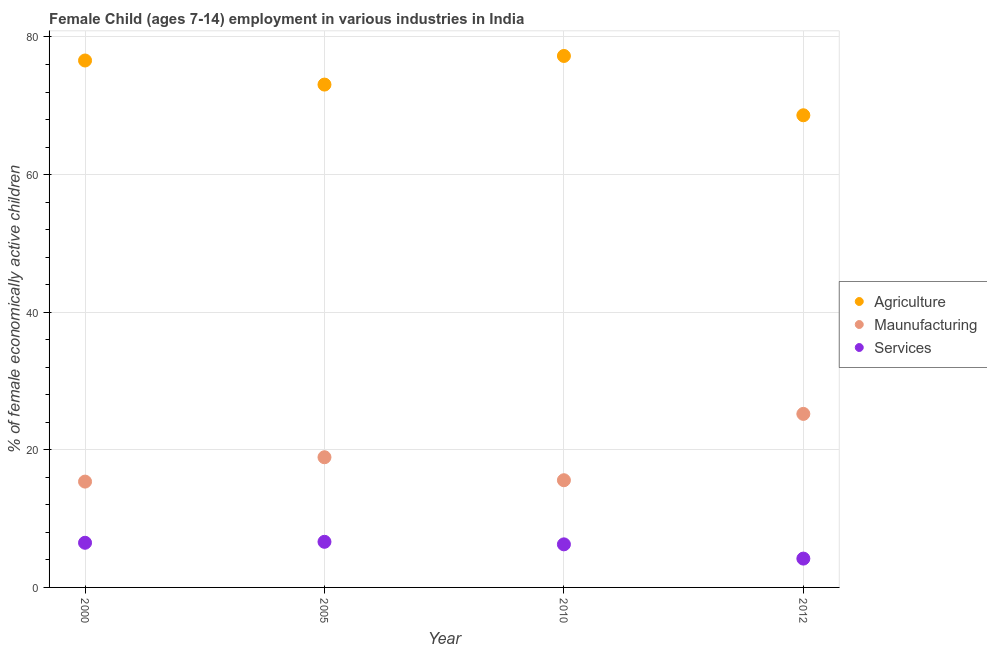What is the percentage of economically active children in services in 2005?
Keep it short and to the point. 6.63. Across all years, what is the maximum percentage of economically active children in agriculture?
Keep it short and to the point. 77.24. Across all years, what is the minimum percentage of economically active children in agriculture?
Offer a terse response. 68.62. In which year was the percentage of economically active children in manufacturing minimum?
Offer a very short reply. 2000. What is the total percentage of economically active children in services in the graph?
Your answer should be compact. 23.57. What is the difference between the percentage of economically active children in manufacturing in 2000 and that in 2010?
Make the answer very short. -0.2. What is the difference between the percentage of economically active children in services in 2012 and the percentage of economically active children in agriculture in 2000?
Your response must be concise. -72.39. What is the average percentage of economically active children in manufacturing per year?
Offer a very short reply. 18.77. In the year 2010, what is the difference between the percentage of economically active children in services and percentage of economically active children in manufacturing?
Provide a succinct answer. -9.32. What is the ratio of the percentage of economically active children in agriculture in 2000 to that in 2005?
Provide a short and direct response. 1.05. Is the difference between the percentage of economically active children in services in 2005 and 2010 greater than the difference between the percentage of economically active children in manufacturing in 2005 and 2010?
Offer a terse response. No. What is the difference between the highest and the second highest percentage of economically active children in services?
Provide a succinct answer. 0.14. What is the difference between the highest and the lowest percentage of economically active children in agriculture?
Your response must be concise. 8.62. In how many years, is the percentage of economically active children in services greater than the average percentage of economically active children in services taken over all years?
Your answer should be compact. 3. Does the percentage of economically active children in manufacturing monotonically increase over the years?
Provide a short and direct response. No. How many years are there in the graph?
Your answer should be very brief. 4. What is the difference between two consecutive major ticks on the Y-axis?
Your answer should be very brief. 20. Does the graph contain grids?
Your answer should be very brief. Yes. How many legend labels are there?
Provide a short and direct response. 3. What is the title of the graph?
Offer a terse response. Female Child (ages 7-14) employment in various industries in India. What is the label or title of the X-axis?
Your response must be concise. Year. What is the label or title of the Y-axis?
Offer a very short reply. % of female economically active children. What is the % of female economically active children in Agriculture in 2000?
Provide a short and direct response. 76.58. What is the % of female economically active children in Maunufacturing in 2000?
Give a very brief answer. 15.38. What is the % of female economically active children of Services in 2000?
Ensure brevity in your answer.  6.49. What is the % of female economically active children of Agriculture in 2005?
Provide a short and direct response. 73.08. What is the % of female economically active children of Maunufacturing in 2005?
Offer a terse response. 18.92. What is the % of female economically active children of Services in 2005?
Offer a very short reply. 6.63. What is the % of female economically active children in Agriculture in 2010?
Keep it short and to the point. 77.24. What is the % of female economically active children in Maunufacturing in 2010?
Your answer should be very brief. 15.58. What is the % of female economically active children of Services in 2010?
Your answer should be compact. 6.26. What is the % of female economically active children in Agriculture in 2012?
Give a very brief answer. 68.62. What is the % of female economically active children in Maunufacturing in 2012?
Offer a very short reply. 25.22. What is the % of female economically active children in Services in 2012?
Offer a terse response. 4.19. Across all years, what is the maximum % of female economically active children of Agriculture?
Give a very brief answer. 77.24. Across all years, what is the maximum % of female economically active children in Maunufacturing?
Ensure brevity in your answer.  25.22. Across all years, what is the maximum % of female economically active children of Services?
Your answer should be compact. 6.63. Across all years, what is the minimum % of female economically active children of Agriculture?
Make the answer very short. 68.62. Across all years, what is the minimum % of female economically active children in Maunufacturing?
Provide a succinct answer. 15.38. Across all years, what is the minimum % of female economically active children of Services?
Your answer should be compact. 4.19. What is the total % of female economically active children in Agriculture in the graph?
Provide a succinct answer. 295.52. What is the total % of female economically active children of Maunufacturing in the graph?
Your answer should be compact. 75.1. What is the total % of female economically active children in Services in the graph?
Offer a terse response. 23.57. What is the difference between the % of female economically active children in Agriculture in 2000 and that in 2005?
Offer a terse response. 3.5. What is the difference between the % of female economically active children in Maunufacturing in 2000 and that in 2005?
Ensure brevity in your answer.  -3.54. What is the difference between the % of female economically active children of Services in 2000 and that in 2005?
Provide a short and direct response. -0.14. What is the difference between the % of female economically active children of Agriculture in 2000 and that in 2010?
Provide a short and direct response. -0.66. What is the difference between the % of female economically active children of Services in 2000 and that in 2010?
Keep it short and to the point. 0.23. What is the difference between the % of female economically active children of Agriculture in 2000 and that in 2012?
Your answer should be very brief. 7.96. What is the difference between the % of female economically active children of Maunufacturing in 2000 and that in 2012?
Offer a very short reply. -9.84. What is the difference between the % of female economically active children of Agriculture in 2005 and that in 2010?
Offer a terse response. -4.16. What is the difference between the % of female economically active children in Maunufacturing in 2005 and that in 2010?
Keep it short and to the point. 3.34. What is the difference between the % of female economically active children in Services in 2005 and that in 2010?
Offer a terse response. 0.37. What is the difference between the % of female economically active children in Agriculture in 2005 and that in 2012?
Keep it short and to the point. 4.46. What is the difference between the % of female economically active children of Services in 2005 and that in 2012?
Make the answer very short. 2.44. What is the difference between the % of female economically active children in Agriculture in 2010 and that in 2012?
Provide a short and direct response. 8.62. What is the difference between the % of female economically active children of Maunufacturing in 2010 and that in 2012?
Your response must be concise. -9.64. What is the difference between the % of female economically active children of Services in 2010 and that in 2012?
Your answer should be compact. 2.07. What is the difference between the % of female economically active children of Agriculture in 2000 and the % of female economically active children of Maunufacturing in 2005?
Offer a very short reply. 57.66. What is the difference between the % of female economically active children of Agriculture in 2000 and the % of female economically active children of Services in 2005?
Your answer should be very brief. 69.95. What is the difference between the % of female economically active children in Maunufacturing in 2000 and the % of female economically active children in Services in 2005?
Make the answer very short. 8.75. What is the difference between the % of female economically active children in Agriculture in 2000 and the % of female economically active children in Services in 2010?
Ensure brevity in your answer.  70.32. What is the difference between the % of female economically active children in Maunufacturing in 2000 and the % of female economically active children in Services in 2010?
Offer a terse response. 9.12. What is the difference between the % of female economically active children of Agriculture in 2000 and the % of female economically active children of Maunufacturing in 2012?
Offer a terse response. 51.36. What is the difference between the % of female economically active children in Agriculture in 2000 and the % of female economically active children in Services in 2012?
Provide a short and direct response. 72.39. What is the difference between the % of female economically active children of Maunufacturing in 2000 and the % of female economically active children of Services in 2012?
Your answer should be very brief. 11.19. What is the difference between the % of female economically active children in Agriculture in 2005 and the % of female economically active children in Maunufacturing in 2010?
Your answer should be compact. 57.5. What is the difference between the % of female economically active children in Agriculture in 2005 and the % of female economically active children in Services in 2010?
Your answer should be very brief. 66.82. What is the difference between the % of female economically active children of Maunufacturing in 2005 and the % of female economically active children of Services in 2010?
Give a very brief answer. 12.66. What is the difference between the % of female economically active children in Agriculture in 2005 and the % of female economically active children in Maunufacturing in 2012?
Offer a very short reply. 47.86. What is the difference between the % of female economically active children of Agriculture in 2005 and the % of female economically active children of Services in 2012?
Your response must be concise. 68.89. What is the difference between the % of female economically active children in Maunufacturing in 2005 and the % of female economically active children in Services in 2012?
Your answer should be very brief. 14.73. What is the difference between the % of female economically active children in Agriculture in 2010 and the % of female economically active children in Maunufacturing in 2012?
Ensure brevity in your answer.  52.02. What is the difference between the % of female economically active children in Agriculture in 2010 and the % of female economically active children in Services in 2012?
Ensure brevity in your answer.  73.05. What is the difference between the % of female economically active children of Maunufacturing in 2010 and the % of female economically active children of Services in 2012?
Provide a succinct answer. 11.39. What is the average % of female economically active children of Agriculture per year?
Ensure brevity in your answer.  73.88. What is the average % of female economically active children of Maunufacturing per year?
Provide a succinct answer. 18.77. What is the average % of female economically active children of Services per year?
Offer a very short reply. 5.89. In the year 2000, what is the difference between the % of female economically active children of Agriculture and % of female economically active children of Maunufacturing?
Provide a short and direct response. 61.2. In the year 2000, what is the difference between the % of female economically active children in Agriculture and % of female economically active children in Services?
Keep it short and to the point. 70.09. In the year 2000, what is the difference between the % of female economically active children of Maunufacturing and % of female economically active children of Services?
Keep it short and to the point. 8.89. In the year 2005, what is the difference between the % of female economically active children of Agriculture and % of female economically active children of Maunufacturing?
Your answer should be very brief. 54.16. In the year 2005, what is the difference between the % of female economically active children in Agriculture and % of female economically active children in Services?
Make the answer very short. 66.45. In the year 2005, what is the difference between the % of female economically active children in Maunufacturing and % of female economically active children in Services?
Give a very brief answer. 12.29. In the year 2010, what is the difference between the % of female economically active children in Agriculture and % of female economically active children in Maunufacturing?
Your response must be concise. 61.66. In the year 2010, what is the difference between the % of female economically active children of Agriculture and % of female economically active children of Services?
Offer a terse response. 70.98. In the year 2010, what is the difference between the % of female economically active children in Maunufacturing and % of female economically active children in Services?
Provide a short and direct response. 9.32. In the year 2012, what is the difference between the % of female economically active children of Agriculture and % of female economically active children of Maunufacturing?
Give a very brief answer. 43.4. In the year 2012, what is the difference between the % of female economically active children of Agriculture and % of female economically active children of Services?
Your answer should be compact. 64.43. In the year 2012, what is the difference between the % of female economically active children in Maunufacturing and % of female economically active children in Services?
Your answer should be very brief. 21.03. What is the ratio of the % of female economically active children in Agriculture in 2000 to that in 2005?
Make the answer very short. 1.05. What is the ratio of the % of female economically active children in Maunufacturing in 2000 to that in 2005?
Provide a short and direct response. 0.81. What is the ratio of the % of female economically active children in Services in 2000 to that in 2005?
Provide a succinct answer. 0.98. What is the ratio of the % of female economically active children in Agriculture in 2000 to that in 2010?
Provide a succinct answer. 0.99. What is the ratio of the % of female economically active children of Maunufacturing in 2000 to that in 2010?
Your answer should be compact. 0.99. What is the ratio of the % of female economically active children of Services in 2000 to that in 2010?
Offer a terse response. 1.04. What is the ratio of the % of female economically active children in Agriculture in 2000 to that in 2012?
Provide a short and direct response. 1.12. What is the ratio of the % of female economically active children in Maunufacturing in 2000 to that in 2012?
Offer a terse response. 0.61. What is the ratio of the % of female economically active children of Services in 2000 to that in 2012?
Your response must be concise. 1.55. What is the ratio of the % of female economically active children in Agriculture in 2005 to that in 2010?
Provide a short and direct response. 0.95. What is the ratio of the % of female economically active children in Maunufacturing in 2005 to that in 2010?
Provide a short and direct response. 1.21. What is the ratio of the % of female economically active children in Services in 2005 to that in 2010?
Your response must be concise. 1.06. What is the ratio of the % of female economically active children of Agriculture in 2005 to that in 2012?
Offer a very short reply. 1.06. What is the ratio of the % of female economically active children in Maunufacturing in 2005 to that in 2012?
Your response must be concise. 0.75. What is the ratio of the % of female economically active children in Services in 2005 to that in 2012?
Provide a short and direct response. 1.58. What is the ratio of the % of female economically active children of Agriculture in 2010 to that in 2012?
Ensure brevity in your answer.  1.13. What is the ratio of the % of female economically active children of Maunufacturing in 2010 to that in 2012?
Give a very brief answer. 0.62. What is the ratio of the % of female economically active children of Services in 2010 to that in 2012?
Offer a terse response. 1.49. What is the difference between the highest and the second highest % of female economically active children in Agriculture?
Ensure brevity in your answer.  0.66. What is the difference between the highest and the second highest % of female economically active children of Maunufacturing?
Give a very brief answer. 6.3. What is the difference between the highest and the second highest % of female economically active children of Services?
Your answer should be compact. 0.14. What is the difference between the highest and the lowest % of female economically active children of Agriculture?
Your answer should be compact. 8.62. What is the difference between the highest and the lowest % of female economically active children in Maunufacturing?
Offer a terse response. 9.84. What is the difference between the highest and the lowest % of female economically active children in Services?
Offer a terse response. 2.44. 